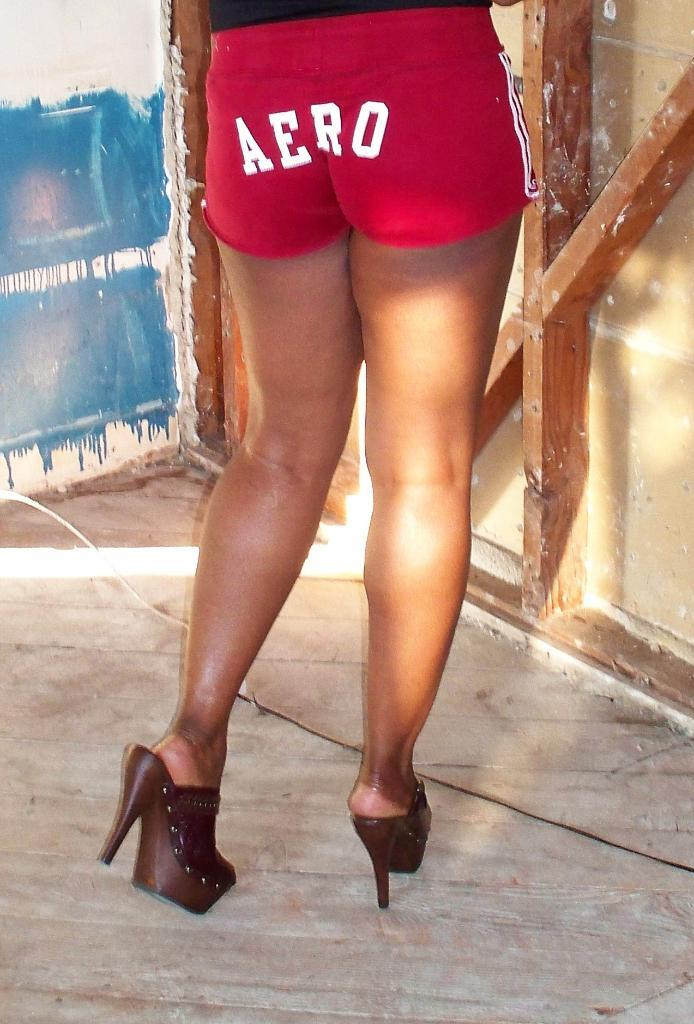<image>
Render a clear and concise summary of the photo. A woman in heels wears short Aero shorts. 